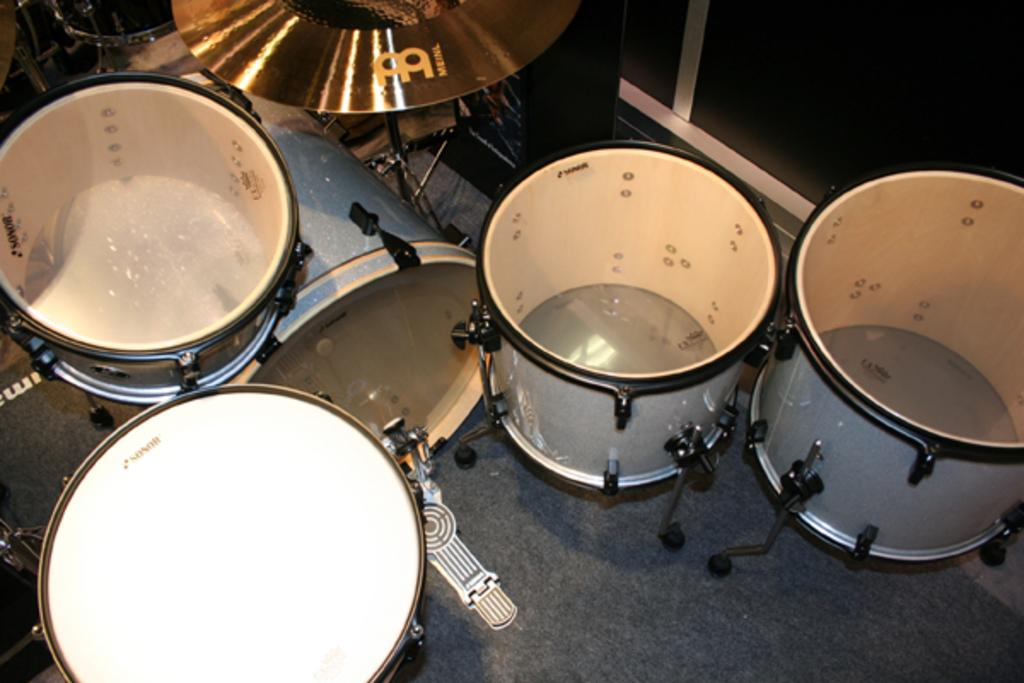What musical instruments are present in the image? There are drums in the image. Where are the drums placed in relation to the floor? The drums are kept on the floor. How are the drums positioned in the image? The drums are located in the middle of the image. What type of machine is used to play the drums in the image? There is no machine present in the image; the drums are played by a person. How many crates are visible in the image? There are no crates present in the image. 